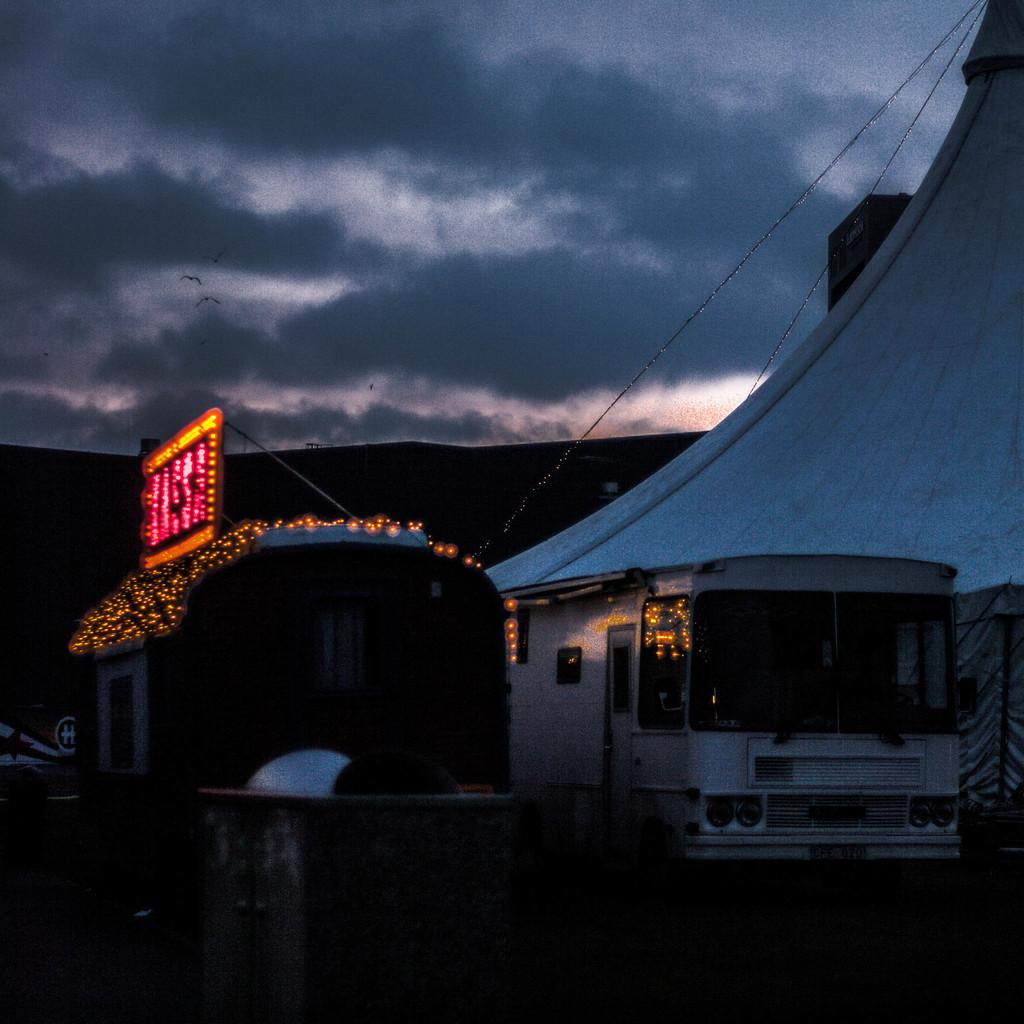What type of vehicle is in the image? There is a vehicle in the image, but the specific type is not mentioned. What feature does the vehicle have? The vehicle has headlights. What other object is present in the image? There is a LED board in the image. Are there any small lights visible in the image? Yes, there are small lights in the image. How would you describe the sky in the image? The sky appears to be cloudy in the image. How many children are playing with the lip in the image? There are no children or lips present in the image. 